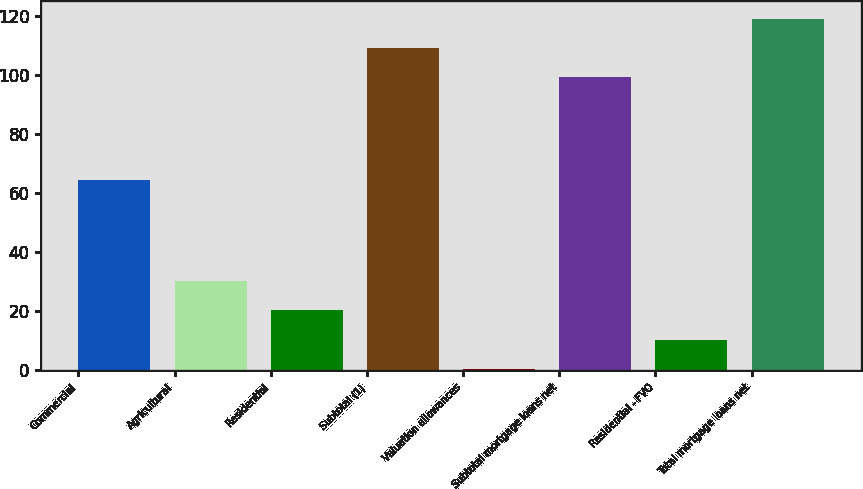Convert chart to OTSL. <chart><loc_0><loc_0><loc_500><loc_500><bar_chart><fcel>Commercial<fcel>Agricultural<fcel>Residential<fcel>Subtotal (1)<fcel>Valuation allowances<fcel>Subtotal mortgage loans net<fcel>Residential - FVO<fcel>Total mortgage loans net<nl><fcel>64.6<fcel>30.35<fcel>20.4<fcel>109.15<fcel>0.5<fcel>99.2<fcel>10.45<fcel>119.1<nl></chart> 